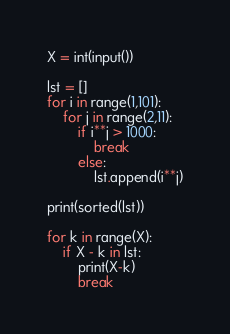Convert code to text. <code><loc_0><loc_0><loc_500><loc_500><_Python_>X = int(input())

lst = []
for i in range(1,101):
    for j in range(2,11):
        if i**j > 1000:
            break
        else:
            lst.append(i**j)

print(sorted(lst))

for k in range(X):
    if X - k in lst:
        print(X-k)
        break
</code> 